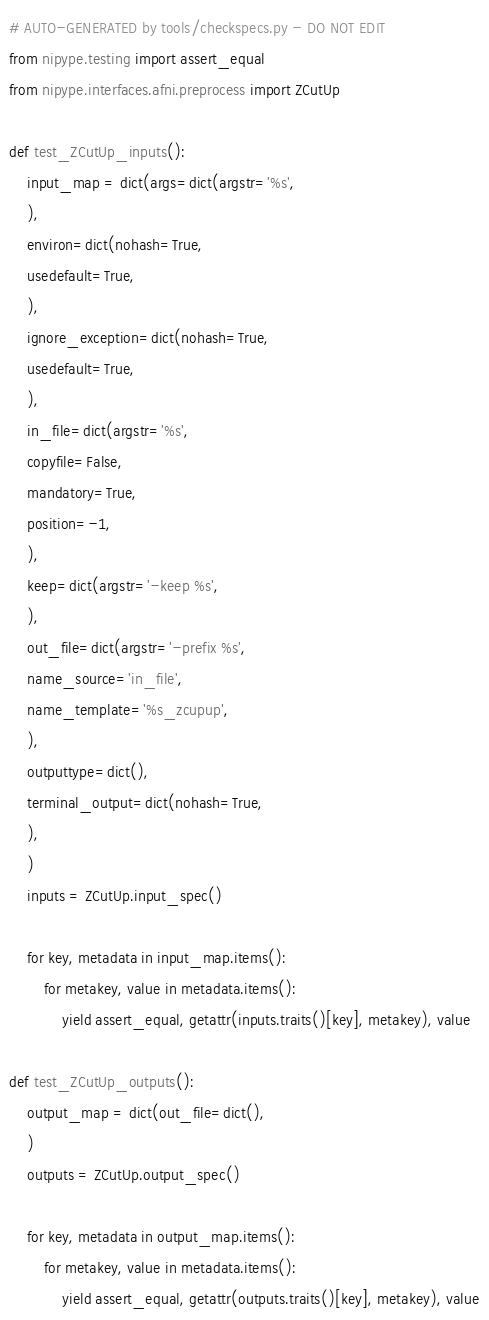<code> <loc_0><loc_0><loc_500><loc_500><_Python_># AUTO-GENERATED by tools/checkspecs.py - DO NOT EDIT
from nipype.testing import assert_equal
from nipype.interfaces.afni.preprocess import ZCutUp

def test_ZCutUp_inputs():
    input_map = dict(args=dict(argstr='%s',
    ),
    environ=dict(nohash=True,
    usedefault=True,
    ),
    ignore_exception=dict(nohash=True,
    usedefault=True,
    ),
    in_file=dict(argstr='%s',
    copyfile=False,
    mandatory=True,
    position=-1,
    ),
    keep=dict(argstr='-keep %s',
    ),
    out_file=dict(argstr='-prefix %s',
    name_source='in_file',
    name_template='%s_zcupup',
    ),
    outputtype=dict(),
    terminal_output=dict(nohash=True,
    ),
    )
    inputs = ZCutUp.input_spec()

    for key, metadata in input_map.items():
        for metakey, value in metadata.items():
            yield assert_equal, getattr(inputs.traits()[key], metakey), value

def test_ZCutUp_outputs():
    output_map = dict(out_file=dict(),
    )
    outputs = ZCutUp.output_spec()

    for key, metadata in output_map.items():
        for metakey, value in metadata.items():
            yield assert_equal, getattr(outputs.traits()[key], metakey), value

</code> 